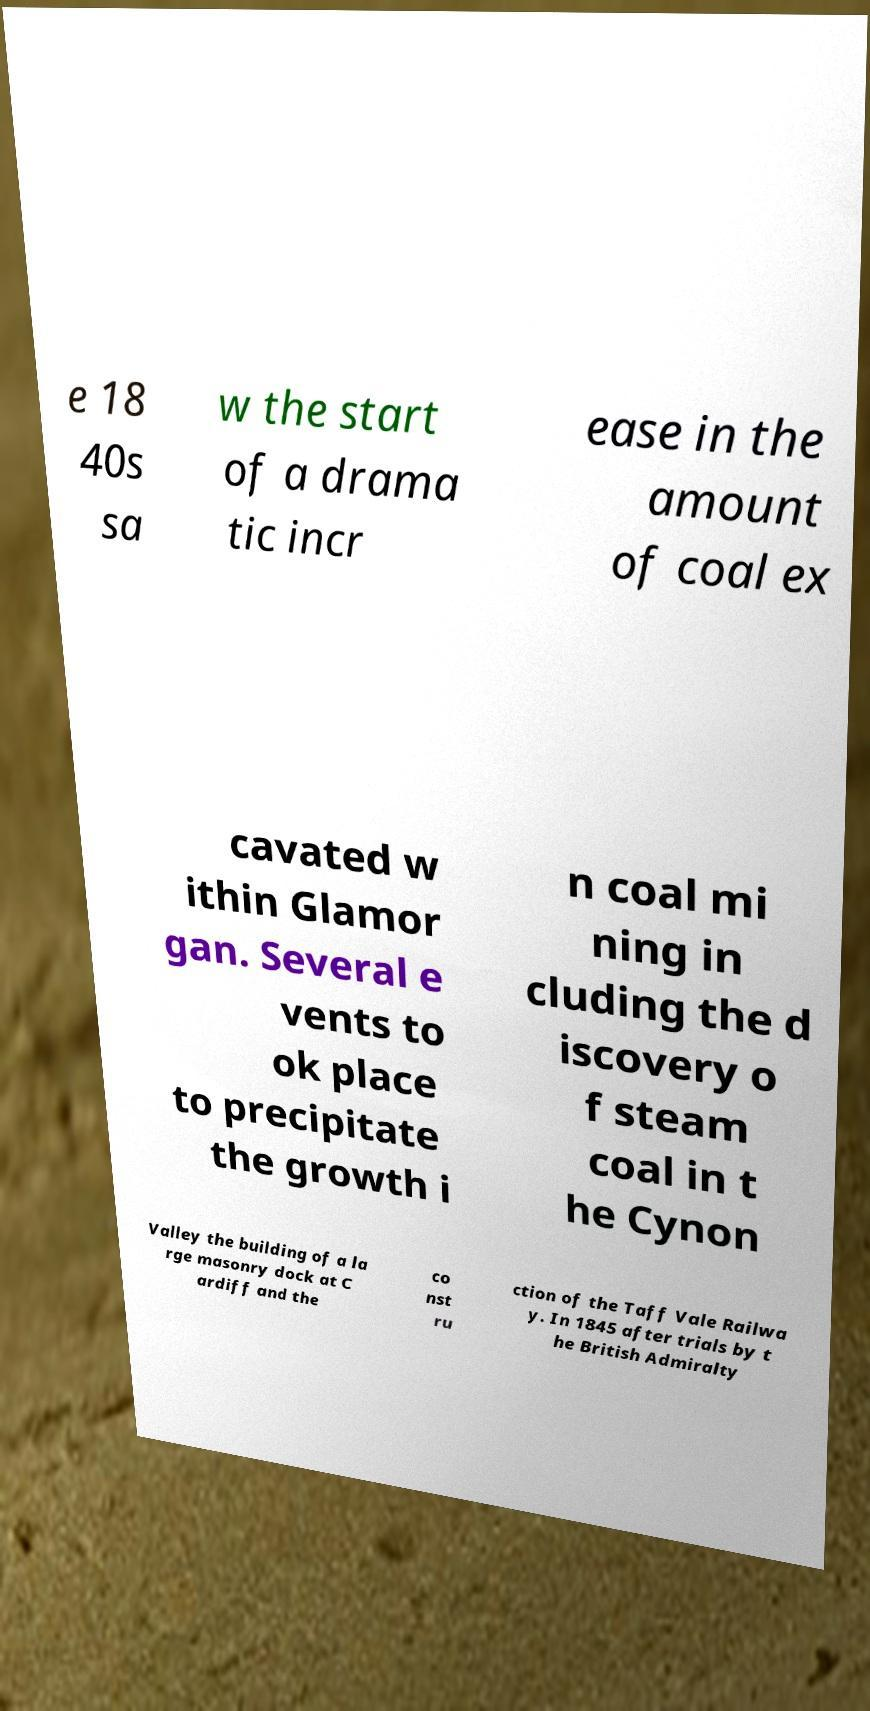Could you extract and type out the text from this image? e 18 40s sa w the start of a drama tic incr ease in the amount of coal ex cavated w ithin Glamor gan. Several e vents to ok place to precipitate the growth i n coal mi ning in cluding the d iscovery o f steam coal in t he Cynon Valley the building of a la rge masonry dock at C ardiff and the co nst ru ction of the Taff Vale Railwa y. In 1845 after trials by t he British Admiralty 